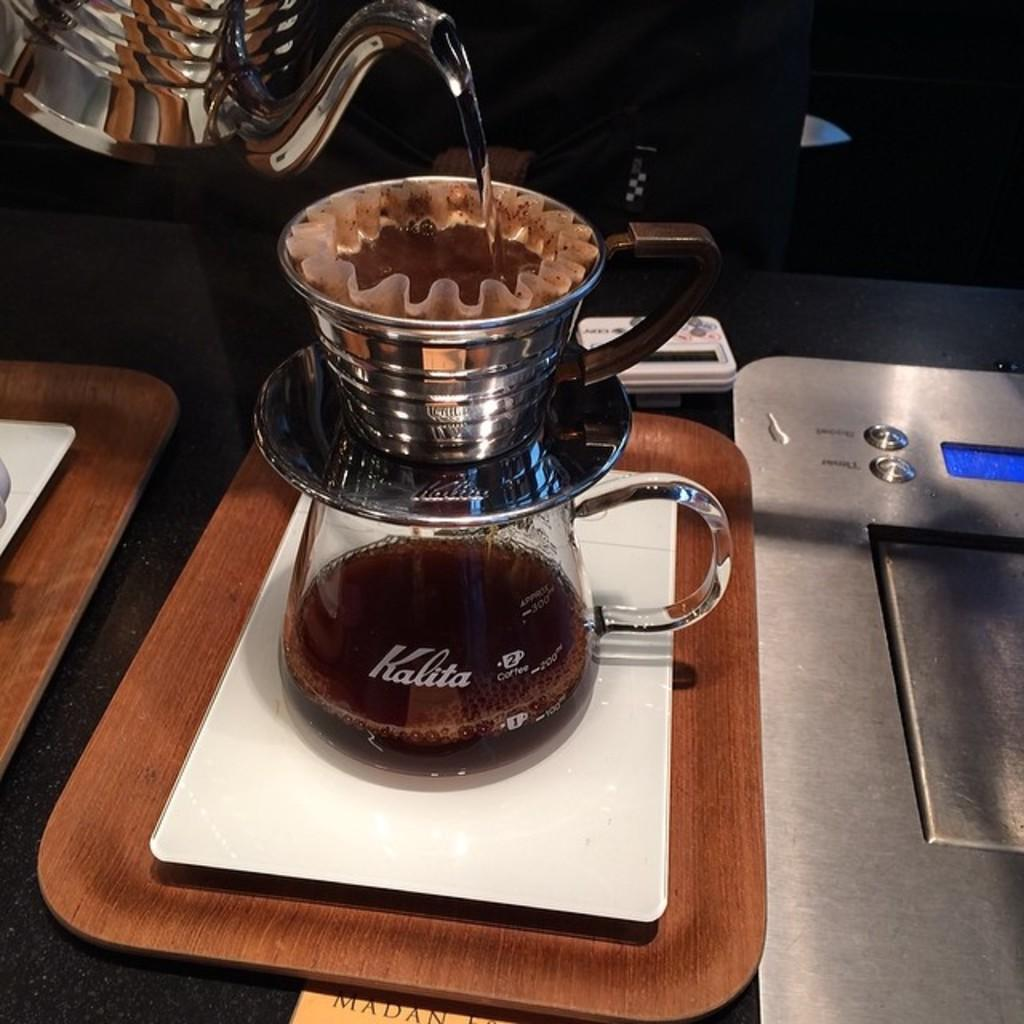Provide a one-sentence caption for the provided image. the water is added to the coffee powder to get a filter coffee and  stores in a bottle which named as kalita. 